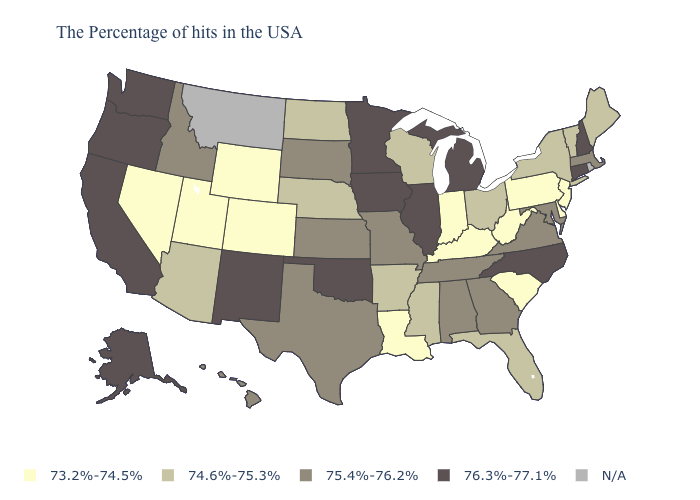Name the states that have a value in the range 74.6%-75.3%?
Quick response, please. Maine, Vermont, New York, Ohio, Florida, Wisconsin, Mississippi, Arkansas, Nebraska, North Dakota, Arizona. Which states have the lowest value in the South?
Concise answer only. Delaware, South Carolina, West Virginia, Kentucky, Louisiana. Name the states that have a value in the range 74.6%-75.3%?
Give a very brief answer. Maine, Vermont, New York, Ohio, Florida, Wisconsin, Mississippi, Arkansas, Nebraska, North Dakota, Arizona. What is the value of New Hampshire?
Give a very brief answer. 76.3%-77.1%. Name the states that have a value in the range 74.6%-75.3%?
Give a very brief answer. Maine, Vermont, New York, Ohio, Florida, Wisconsin, Mississippi, Arkansas, Nebraska, North Dakota, Arizona. Does Idaho have the lowest value in the West?
Answer briefly. No. Does the first symbol in the legend represent the smallest category?
Short answer required. Yes. What is the value of Florida?
Write a very short answer. 74.6%-75.3%. Among the states that border Washington , which have the lowest value?
Short answer required. Idaho. What is the lowest value in the USA?
Write a very short answer. 73.2%-74.5%. What is the highest value in the USA?
Be succinct. 76.3%-77.1%. Which states have the lowest value in the USA?
Answer briefly. New Jersey, Delaware, Pennsylvania, South Carolina, West Virginia, Kentucky, Indiana, Louisiana, Wyoming, Colorado, Utah, Nevada. 